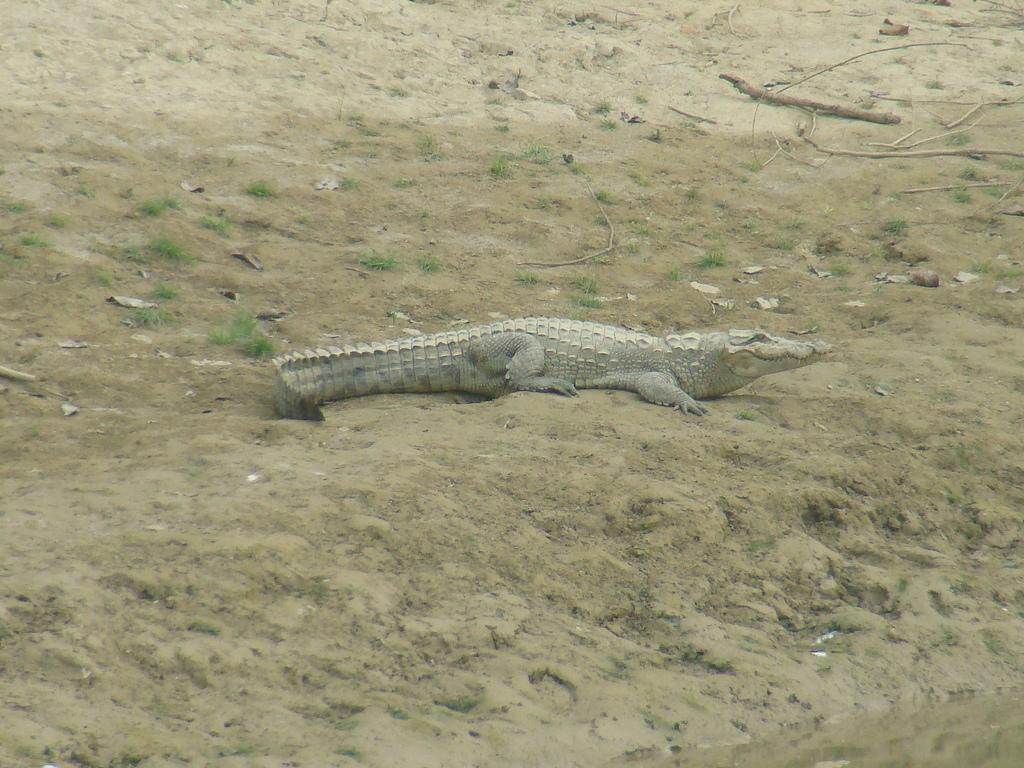What type of animal is in the image? There is a crocodile in the image. What type of terrain is visible in the image? The image contains sand and grass. What is the water source in the image? There is water visible in the image. What riddle is the crocodile trying to solve in the image? There is no indication in the image that the crocodile is trying to solve a riddle. 